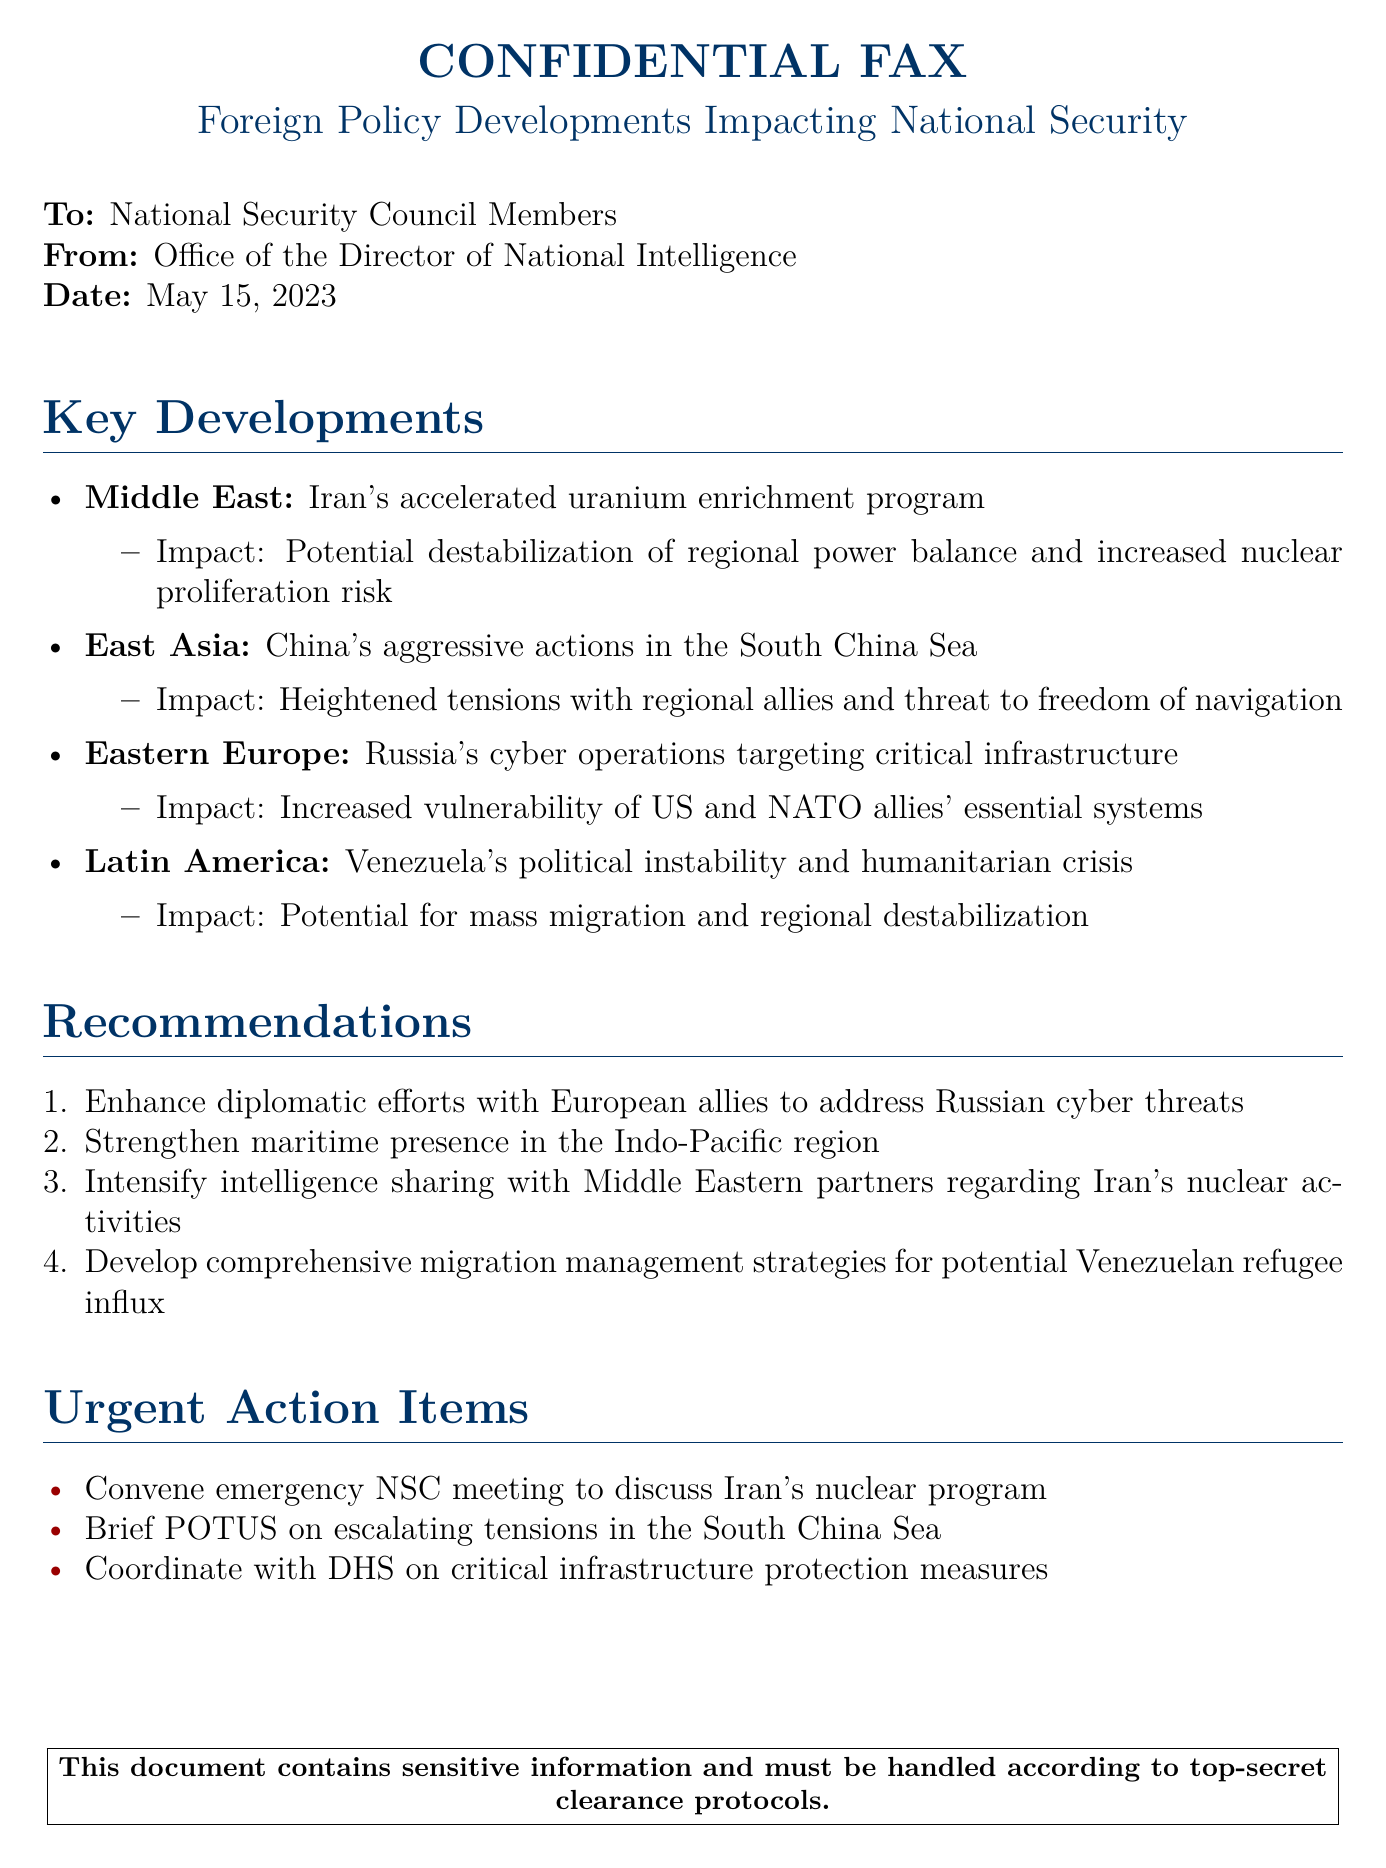What is the date of the fax? The date of the fax is specified in the document under the 'Date' section.
Answer: May 15, 2023 Who is the sender of the fax? The sender is identified in the document as the Office of the Director of National Intelligence.
Answer: Office of the Director of National Intelligence What region is affected by Iran's uranium enrichment program? The document mentions the Middle East in relation to Iran's nuclear activities.
Answer: Middle East What urgent action is recommended regarding Venezuela? The document outlines a need for developing strategies specifically related to Venezuelan refugees.
Answer: Comprehensive migration management strategies Which country is involved in aggressive actions in the South China Sea? The document explicitly states that China is involved in these actions.
Answer: China What type of operations are being conducted by Russia? The document indicates that Russia is conducting cyber operations targeting critical infrastructure.
Answer: Cyber operations How many key developments are listed in the document? The total number of key developments can be counted from the itemized list in the document.
Answer: Four What is the primary impact of Iran’s accelerated uranium enrichment program? The impact is described in the document as a potential destabilization of regional power balance.
Answer: Potential destabilization of regional power balance Who needs to be briefed about the escalating tensions in the South China Sea? The document specifies that the President of the United States should be briefed.
Answer: POTUS 